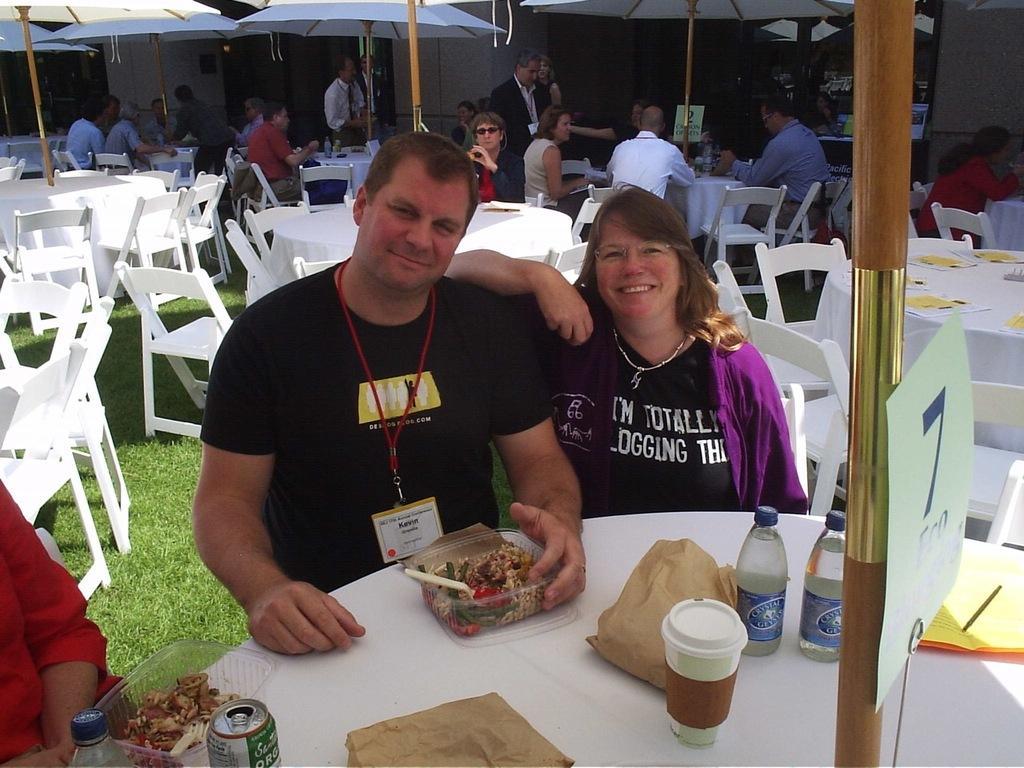Could you give a brief overview of what you see in this image? In this image we can see two people sitting on chairs near table. There are food bowls, covers, bottles and tins on the table. In the background we can see tables and chairs, umbrellas and people. 